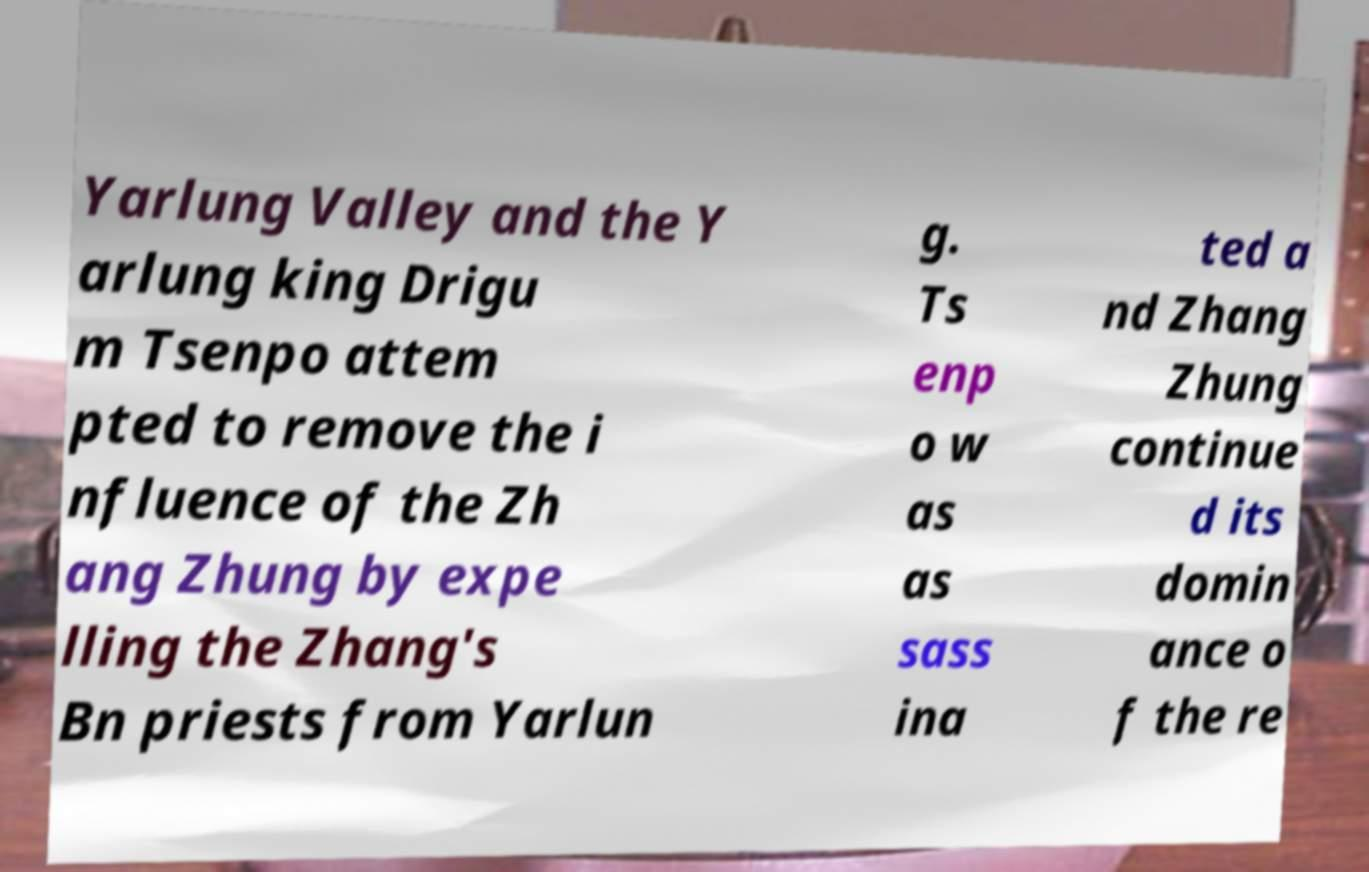Could you assist in decoding the text presented in this image and type it out clearly? Yarlung Valley and the Y arlung king Drigu m Tsenpo attem pted to remove the i nfluence of the Zh ang Zhung by expe lling the Zhang's Bn priests from Yarlun g. Ts enp o w as as sass ina ted a nd Zhang Zhung continue d its domin ance o f the re 